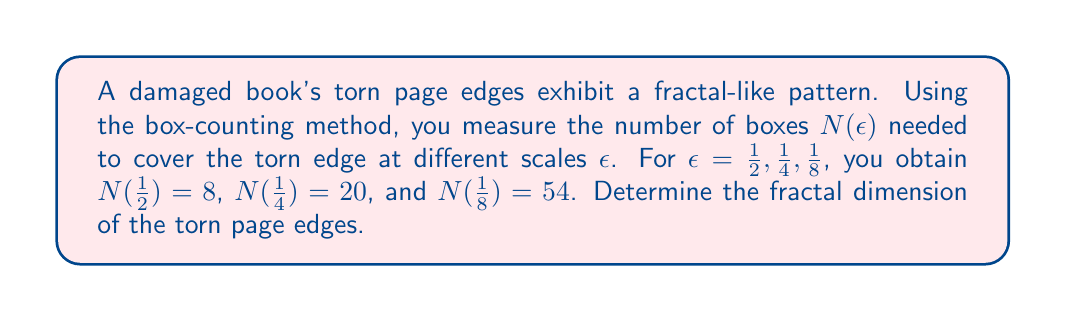What is the answer to this math problem? To determine the fractal dimension using the box-counting method, we follow these steps:

1) The fractal dimension $D$ is given by the formula:

   $$D = \lim_{\epsilon \to 0} \frac{\log N(\epsilon)}{\log(1/\epsilon)}$$

2) We can estimate $D$ by plotting $\log N(\epsilon)$ against $\log(1/\epsilon)$ and finding the slope of the best-fit line.

3) Let's calculate $\log N(\epsilon)$ and $\log(1/\epsilon)$ for each scale:

   For $\epsilon = 1/2$: $\log(1/\epsilon) = \log 2 \approx 0.301$, $\log N(\epsilon) = \log 8 = 3 \log 2 \approx 0.903$
   For $\epsilon = 1/4$: $\log(1/\epsilon) = \log 4 = 2 \log 2 \approx 0.602$, $\log N(\epsilon) = \log 20 \approx 1.301$
   For $\epsilon = 1/8$: $\log(1/\epsilon) = \log 8 = 3 \log 2 \approx 0.903$, $\log N(\epsilon) = \log 54 \approx 1.732$

4) We can use the slope formula between the first and last points to estimate $D$:

   $$D \approx \frac{1.732 - 0.903}{0.903 - 0.301} = \frac{0.829}{0.602} \approx 1.377$$

5) This value suggests that the fractal dimension of the torn page edges is approximately 1.377, which is between 1 (a smooth line) and 2 (a filled plane), indicating a complex, fractal-like structure.
Answer: $D \approx 1.377$ 